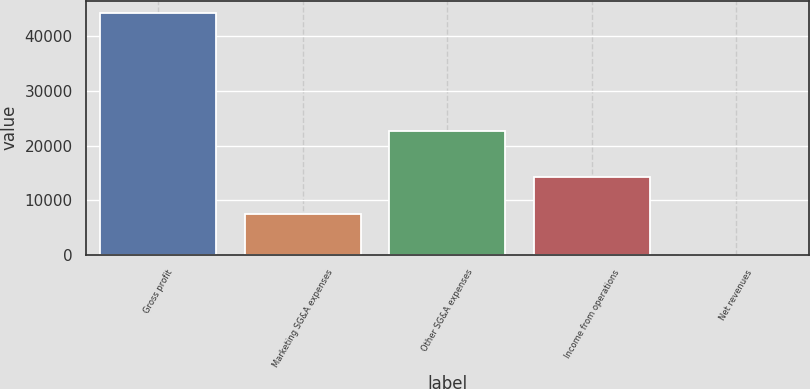Convert chart to OTSL. <chart><loc_0><loc_0><loc_500><loc_500><bar_chart><fcel>Gross profit<fcel>Marketing SG&A expenses<fcel>Other SG&A expenses<fcel>Income from operations<fcel>Net revenues<nl><fcel>44312<fcel>7507<fcel>22625<fcel>14180<fcel>20.4<nl></chart> 